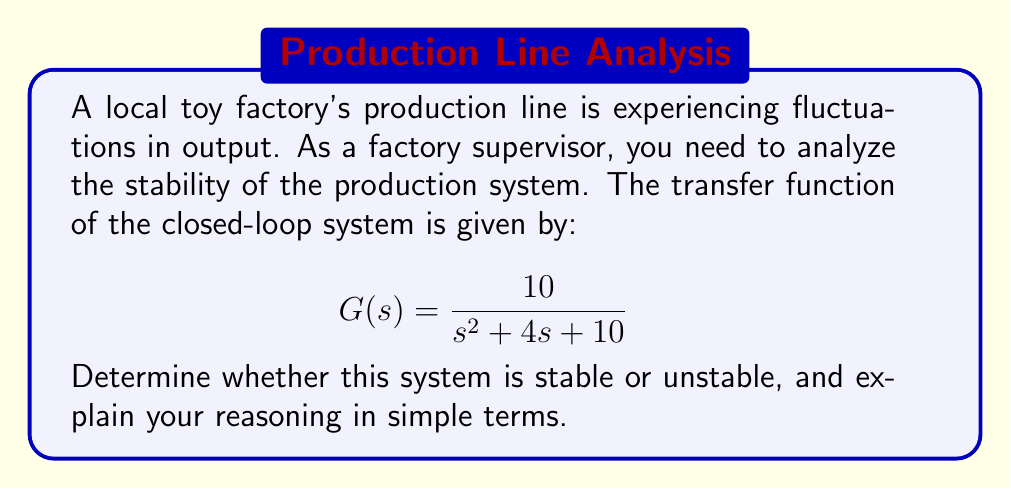Give your solution to this math problem. To analyze the stability of this system, we need to look at its characteristic equation. For a system to be stable, all roots of the characteristic equation must have negative real parts.

1. The characteristic equation is the denominator of the transfer function set to zero:
   $$s^2 + 4s + 10 = 0$$

2. We can solve this equation using the quadratic formula:
   $$s = \frac{-b \pm \sqrt{b^2 - 4ac}}{2a}$$
   where $a=1$, $b=4$, and $c=10$

3. Substituting these values:
   $$s = \frac{-4 \pm \sqrt{4^2 - 4(1)(10)}}{2(1)}$$
   $$s = \frac{-4 \pm \sqrt{16 - 40}}{2}$$
   $$s = \frac{-4 \pm \sqrt{-24}}{2}$$

4. Simplifying:
   $$s = -2 \pm j\sqrt{6}$$

5. The roots are complex conjugates with a negative real part (-2) and an imaginary part ($\pm j\sqrt{6}$).

In simple terms, this means the production line will settle down to a steady state after any disturbance, rather than continuing to fluctuate wildly or grow out of control. The negative real part (-2) indicates that any oscillations will decrease over time, bringing the system back to equilibrium.
Answer: The system is stable because both roots of the characteristic equation have negative real parts: $s = -2 \pm j\sqrt{6}$. 